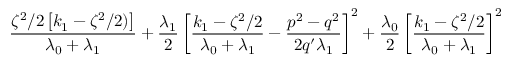Convert formula to latex. <formula><loc_0><loc_0><loc_500><loc_500>\frac { \zeta ^ { 2 } / 2 \left [ k _ { 1 } - \zeta ^ { 2 } / 2 ) \right ] } { \lambda _ { 0 } + \lambda _ { 1 } } + \frac { \lambda _ { 1 } } { 2 } \left [ \frac { k _ { 1 } - \zeta ^ { 2 } / 2 } { \lambda _ { 0 } + \lambda _ { 1 } } - \frac { p ^ { 2 } - q ^ { 2 } } { 2 q ^ { \prime } \lambda _ { 1 } } \right ] ^ { 2 } + \frac { \lambda _ { 0 } } { 2 } \left [ \frac { k _ { 1 } - \zeta ^ { 2 } / 2 } { \lambda _ { 0 } + \lambda _ { 1 } } \right ] ^ { 2 }</formula> 